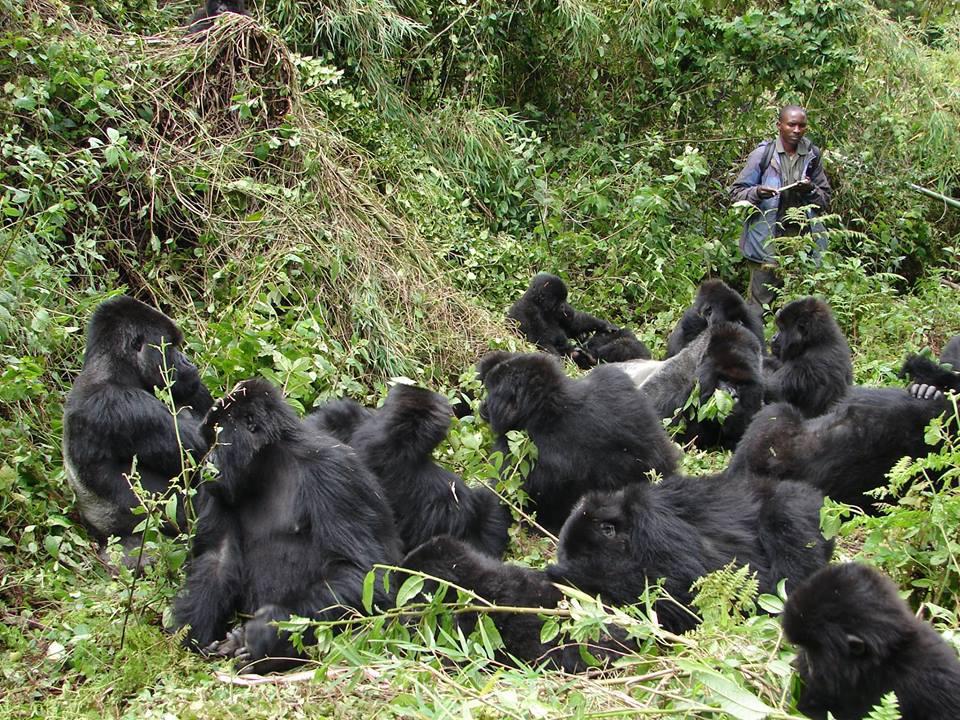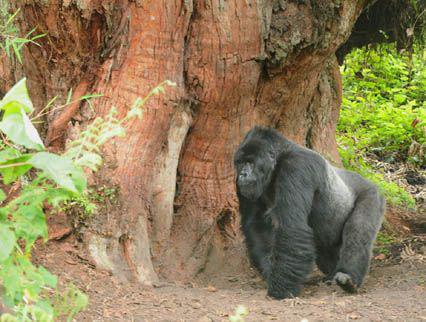The first image is the image on the left, the second image is the image on the right. Examine the images to the left and right. Is the description "The right image contains no more than one gorilla." accurate? Answer yes or no. Yes. The first image is the image on the left, the second image is the image on the right. Given the left and right images, does the statement "A camera-facing person is holding a notebook and standing near a group of gorillas in a forest." hold true? Answer yes or no. Yes. 